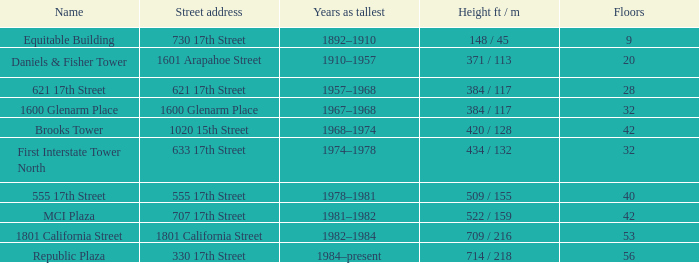What is the vertical measurement of a building that has 40 levels? 509 / 155. 